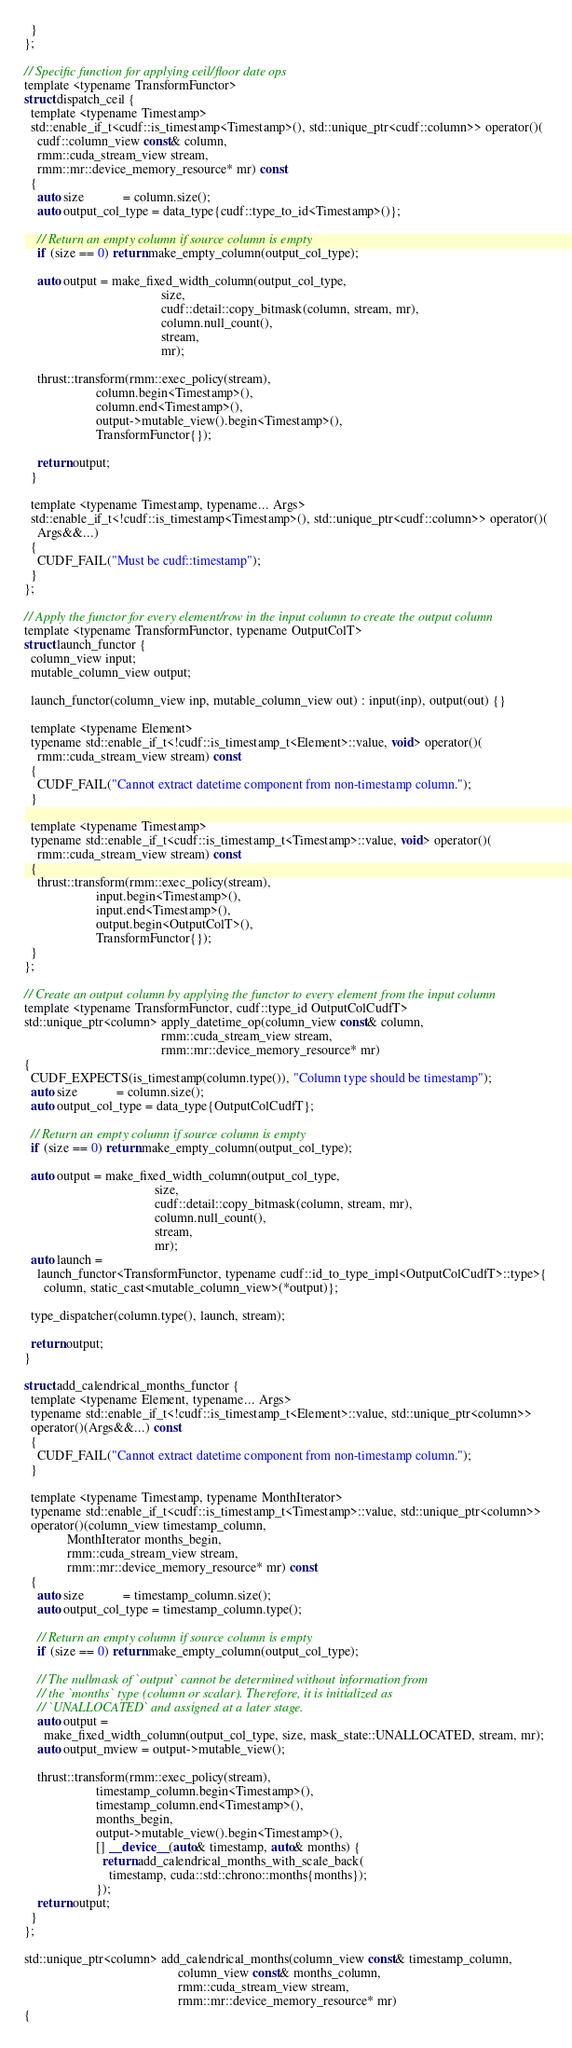<code> <loc_0><loc_0><loc_500><loc_500><_Cuda_>  }
};

// Specific function for applying ceil/floor date ops
template <typename TransformFunctor>
struct dispatch_ceil {
  template <typename Timestamp>
  std::enable_if_t<cudf::is_timestamp<Timestamp>(), std::unique_ptr<cudf::column>> operator()(
    cudf::column_view const& column,
    rmm::cuda_stream_view stream,
    rmm::mr::device_memory_resource* mr) const
  {
    auto size            = column.size();
    auto output_col_type = data_type{cudf::type_to_id<Timestamp>()};

    // Return an empty column if source column is empty
    if (size == 0) return make_empty_column(output_col_type);

    auto output = make_fixed_width_column(output_col_type,
                                          size,
                                          cudf::detail::copy_bitmask(column, stream, mr),
                                          column.null_count(),
                                          stream,
                                          mr);

    thrust::transform(rmm::exec_policy(stream),
                      column.begin<Timestamp>(),
                      column.end<Timestamp>(),
                      output->mutable_view().begin<Timestamp>(),
                      TransformFunctor{});

    return output;
  }

  template <typename Timestamp, typename... Args>
  std::enable_if_t<!cudf::is_timestamp<Timestamp>(), std::unique_ptr<cudf::column>> operator()(
    Args&&...)
  {
    CUDF_FAIL("Must be cudf::timestamp");
  }
};

// Apply the functor for every element/row in the input column to create the output column
template <typename TransformFunctor, typename OutputColT>
struct launch_functor {
  column_view input;
  mutable_column_view output;

  launch_functor(column_view inp, mutable_column_view out) : input(inp), output(out) {}

  template <typename Element>
  typename std::enable_if_t<!cudf::is_timestamp_t<Element>::value, void> operator()(
    rmm::cuda_stream_view stream) const
  {
    CUDF_FAIL("Cannot extract datetime component from non-timestamp column.");
  }

  template <typename Timestamp>
  typename std::enable_if_t<cudf::is_timestamp_t<Timestamp>::value, void> operator()(
    rmm::cuda_stream_view stream) const
  {
    thrust::transform(rmm::exec_policy(stream),
                      input.begin<Timestamp>(),
                      input.end<Timestamp>(),
                      output.begin<OutputColT>(),
                      TransformFunctor{});
  }
};

// Create an output column by applying the functor to every element from the input column
template <typename TransformFunctor, cudf::type_id OutputColCudfT>
std::unique_ptr<column> apply_datetime_op(column_view const& column,
                                          rmm::cuda_stream_view stream,
                                          rmm::mr::device_memory_resource* mr)
{
  CUDF_EXPECTS(is_timestamp(column.type()), "Column type should be timestamp");
  auto size            = column.size();
  auto output_col_type = data_type{OutputColCudfT};

  // Return an empty column if source column is empty
  if (size == 0) return make_empty_column(output_col_type);

  auto output = make_fixed_width_column(output_col_type,
                                        size,
                                        cudf::detail::copy_bitmask(column, stream, mr),
                                        column.null_count(),
                                        stream,
                                        mr);
  auto launch =
    launch_functor<TransformFunctor, typename cudf::id_to_type_impl<OutputColCudfT>::type>{
      column, static_cast<mutable_column_view>(*output)};

  type_dispatcher(column.type(), launch, stream);

  return output;
}

struct add_calendrical_months_functor {
  template <typename Element, typename... Args>
  typename std::enable_if_t<!cudf::is_timestamp_t<Element>::value, std::unique_ptr<column>>
  operator()(Args&&...) const
  {
    CUDF_FAIL("Cannot extract datetime component from non-timestamp column.");
  }

  template <typename Timestamp, typename MonthIterator>
  typename std::enable_if_t<cudf::is_timestamp_t<Timestamp>::value, std::unique_ptr<column>>
  operator()(column_view timestamp_column,
             MonthIterator months_begin,
             rmm::cuda_stream_view stream,
             rmm::mr::device_memory_resource* mr) const
  {
    auto size            = timestamp_column.size();
    auto output_col_type = timestamp_column.type();

    // Return an empty column if source column is empty
    if (size == 0) return make_empty_column(output_col_type);

    // The nullmask of `output` cannot be determined without information from
    // the `months` type (column or scalar). Therefore, it is initialized as
    // `UNALLOCATED` and assigned at a later stage.
    auto output =
      make_fixed_width_column(output_col_type, size, mask_state::UNALLOCATED, stream, mr);
    auto output_mview = output->mutable_view();

    thrust::transform(rmm::exec_policy(stream),
                      timestamp_column.begin<Timestamp>(),
                      timestamp_column.end<Timestamp>(),
                      months_begin,
                      output->mutable_view().begin<Timestamp>(),
                      [] __device__(auto& timestamp, auto& months) {
                        return add_calendrical_months_with_scale_back(
                          timestamp, cuda::std::chrono::months{months});
                      });
    return output;
  }
};

std::unique_ptr<column> add_calendrical_months(column_view const& timestamp_column,
                                               column_view const& months_column,
                                               rmm::cuda_stream_view stream,
                                               rmm::mr::device_memory_resource* mr)
{</code> 